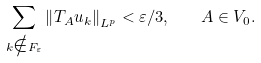Convert formula to latex. <formula><loc_0><loc_0><loc_500><loc_500>\sum _ { k \notin F _ { \varepsilon } } \left \| T _ { A } u _ { k } \right \| _ { L ^ { p } } < \varepsilon / 3 , \quad A \in V _ { 0 } .</formula> 